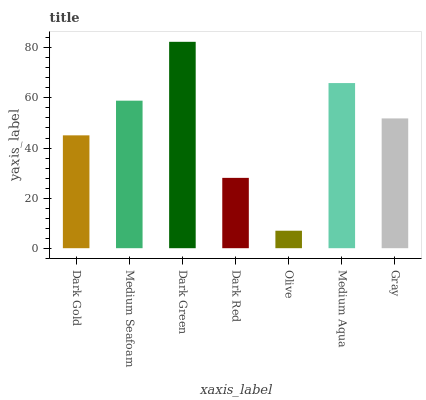Is Olive the minimum?
Answer yes or no. Yes. Is Dark Green the maximum?
Answer yes or no. Yes. Is Medium Seafoam the minimum?
Answer yes or no. No. Is Medium Seafoam the maximum?
Answer yes or no. No. Is Medium Seafoam greater than Dark Gold?
Answer yes or no. Yes. Is Dark Gold less than Medium Seafoam?
Answer yes or no. Yes. Is Dark Gold greater than Medium Seafoam?
Answer yes or no. No. Is Medium Seafoam less than Dark Gold?
Answer yes or no. No. Is Gray the high median?
Answer yes or no. Yes. Is Gray the low median?
Answer yes or no. Yes. Is Olive the high median?
Answer yes or no. No. Is Dark Red the low median?
Answer yes or no. No. 